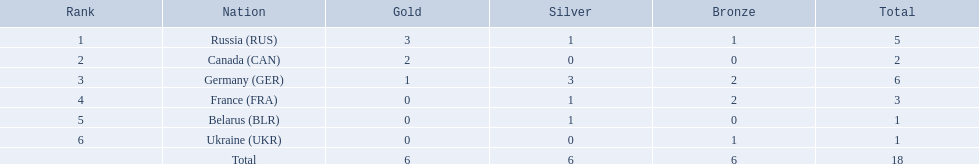Which countries obtained a minimum of one gold medal? Russia (RUS), Canada (CAN), Germany (GER). From this group of countries, which ones also earned at least one silver medal? Russia (RUS), Germany (GER). Among the remaining countries, which had the greatest overall number of medals? Germany (GER). 